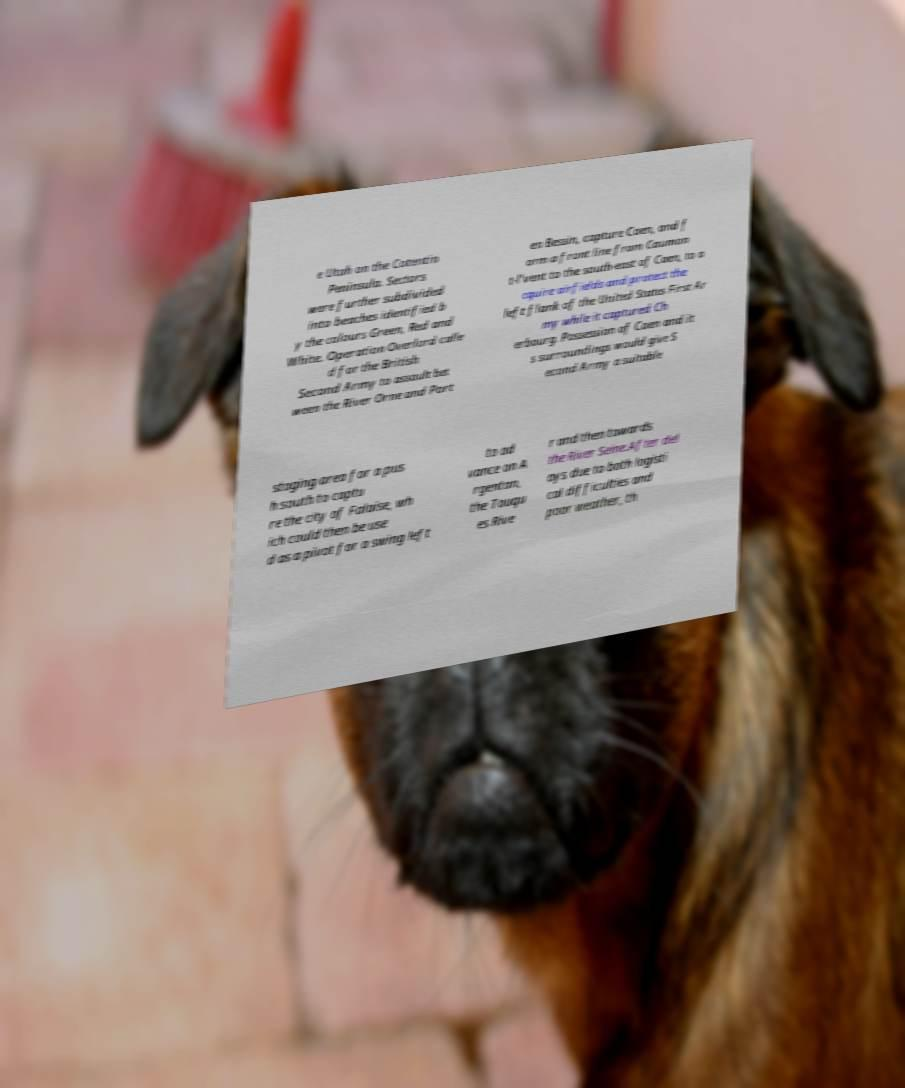Can you accurately transcribe the text from the provided image for me? e Utah on the Cotentin Peninsula. Sectors were further subdivided into beaches identified b y the colours Green, Red and White. Operation Overlord calle d for the British Second Army to assault bet ween the River Orne and Port en Bessin, capture Caen, and f orm a front line from Caumon t-l'vent to the south-east of Caen, to a cquire airfields and protect the left flank of the United States First Ar my while it captured Ch erbourg. Possession of Caen and it s surroundings would give S econd Army a suitable staging area for a pus h south to captu re the city of Falaise, wh ich could then be use d as a pivot for a swing left to ad vance on A rgentan, the Touqu es Rive r and then towards the River Seine.After del ays due to both logisti cal difficulties and poor weather, th 